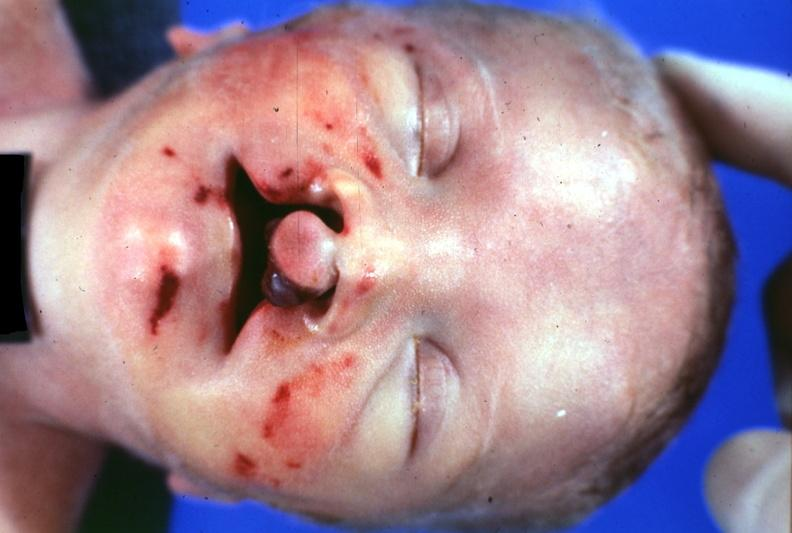what is present?
Answer the question using a single word or phrase. Bilateral cleft palate 